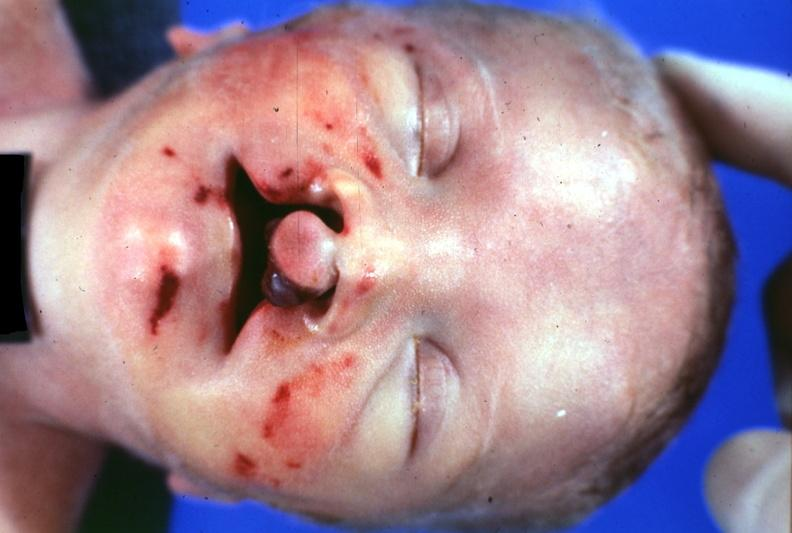what is present?
Answer the question using a single word or phrase. Bilateral cleft palate 